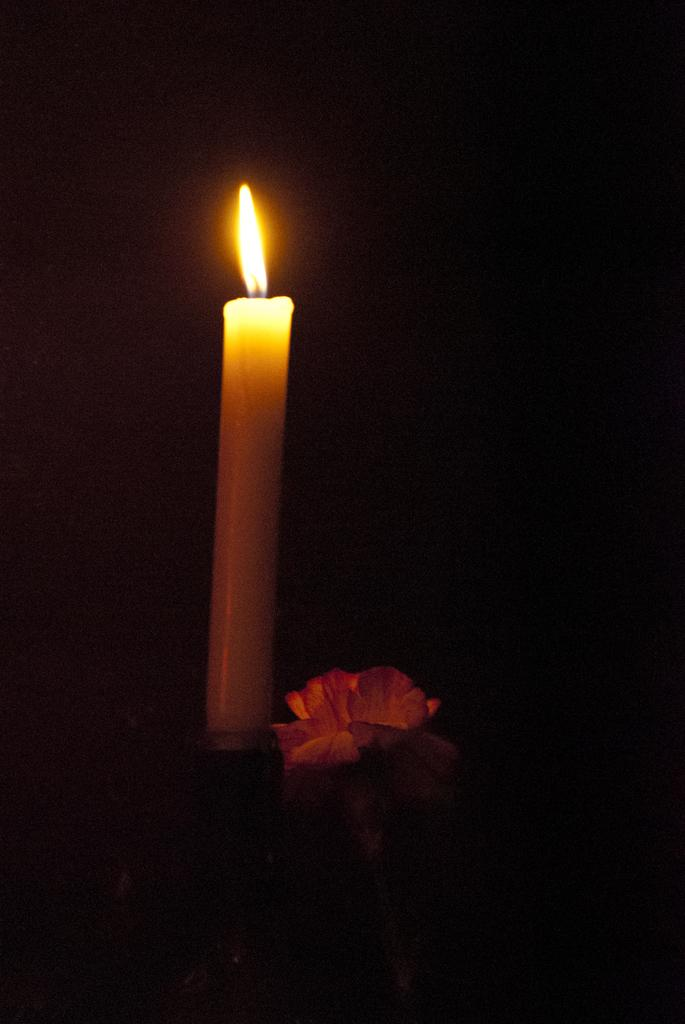What object is present in the image that produces light? There is a candle in the image that produces light. What is the source of the light in the image? There is a flame in the image that is the source of the light. What type of plant is visible in the image? There is a flower in the image. How would you describe the overall lighting in the image? The background of the image is dark. How many bridges can be seen crossing the river in the image? There is no river or bridge present in the image. What type of fruit is hanging from the flower in the image? There is no fruit present in the image, and the flower is not associated with any fruit. 